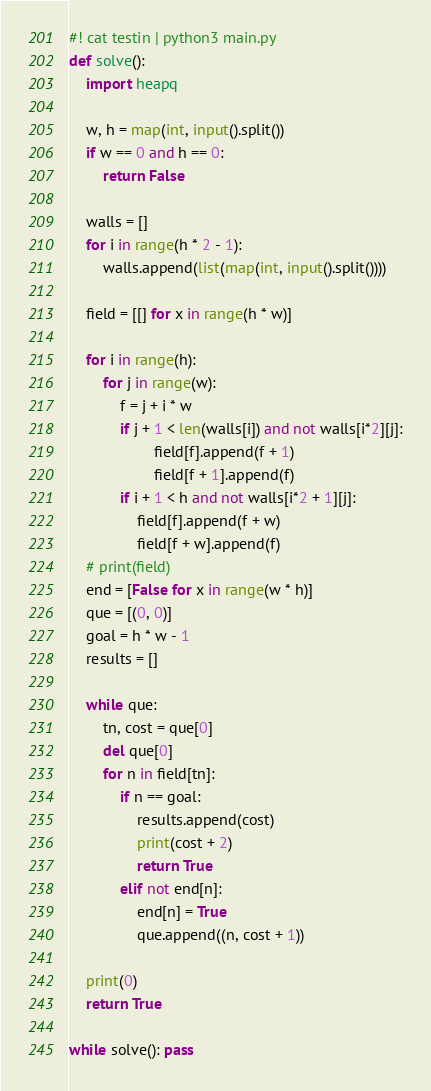Convert code to text. <code><loc_0><loc_0><loc_500><loc_500><_Python_>#! cat testin | python3 main.py
def solve():
    import heapq

    w, h = map(int, input().split())
    if w == 0 and h == 0:
        return False

    walls = []
    for i in range(h * 2 - 1):
        walls.append(list(map(int, input().split())))

    field = [[] for x in range(h * w)]

    for i in range(h):
        for j in range(w):
            f = j + i * w
            if j + 1 < len(walls[i]) and not walls[i*2][j]:
                    field[f].append(f + 1)
                    field[f + 1].append(f)
            if i + 1 < h and not walls[i*2 + 1][j]:
                field[f].append(f + w)
                field[f + w].append(f)
    # print(field)
    end = [False for x in range(w * h)]
    que = [(0, 0)]
    goal = h * w - 1
    results = []

    while que:
        tn, cost = que[0]
        del que[0]
        for n in field[tn]:
            if n == goal:
                results.append(cost)
                print(cost + 2)
                return True
            elif not end[n]:
                end[n] = True
                que.append((n, cost + 1))

    print(0)
    return True

while solve(): pass</code> 